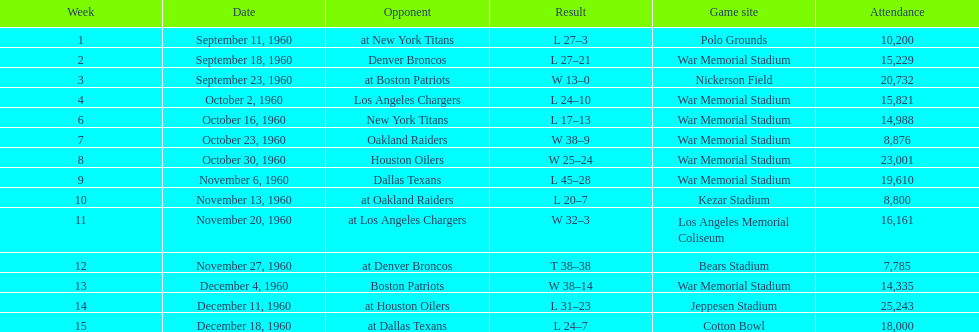Which date had the highest attendance? December 11, 1960. 